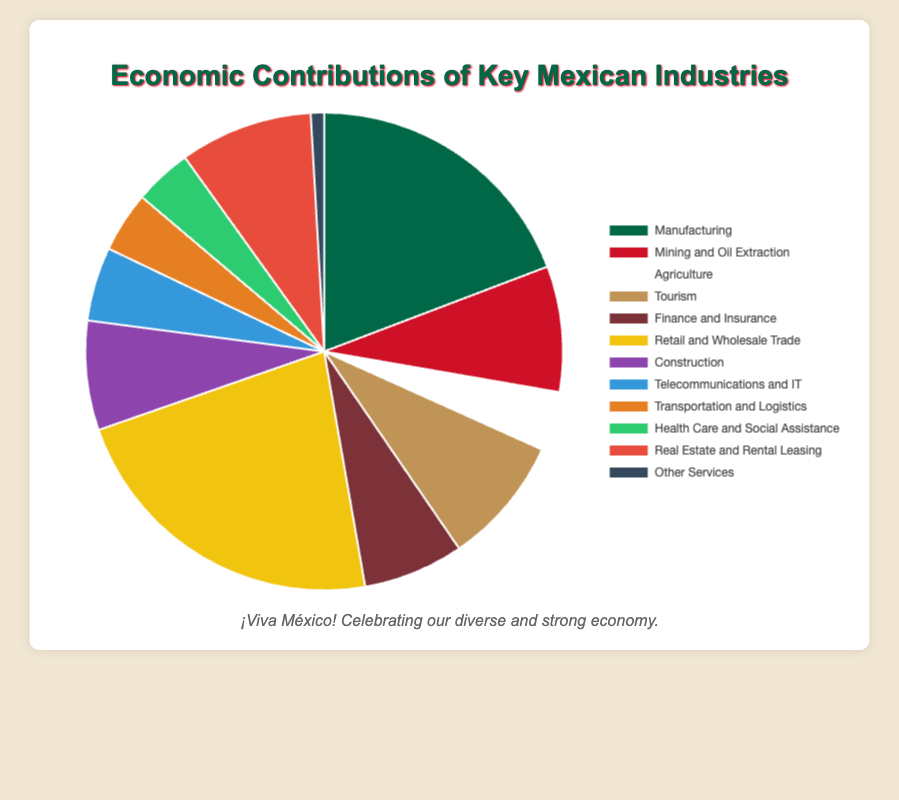What percentage of the economy does Manufacturing contribute? To determine the percentage, refer to the segment labeled "Manufacturing" in the pie chart.
Answer: 19.2% Which industry contributes more to the economy: Mining and Oil Extraction or Tourism? Compare the percentages: Mining and Oil Extraction contributes 8.5% while Tourism contributes 8.7%.
Answer: Tourism What is the total combined percentage of Agriculture, Construction, and Health Care and Social Assistance? Add the percentages of the three industries: Agriculture (4.0%) + Construction (7.4%) + Health Care and Social Assistance (3.9%) = 15.3%
Answer: 15.3% Which industry is depicted in blue and what percentage does it contribute? Identify the blue segment in the pie chart and check the corresponding label.
Answer: Telecommunications and IT, 5% By how much does Real Estate and Rental Leasing exceed Agriculture in their economic contributions? Subtract the percentage of Agriculture from that of Real Estate and Rental Leasing: 9.0% - 4.0% = 5.0%
Answer: 5.0% What percentage does the Retail and Wholesale Trade industry contribute to the economy? Look at the segment labeled "Retail and Wholesale Trade" in the pie chart.
Answer: 22.4% Arrange the following industries in ascending order of their economic contributions: Finance and Insurance, Transportation and Logistics, Real Estate and Rental Leasing. Compare the percentages of each industry: Transportation and Logistics (4.1%), Finance and Insurance (6.8%), Real Estate and Rental Leasing (9.0%).
Answer: Transportation and Logistics, Finance and Insurance, Real Estate and Rental Leasing Does Mining and Oil Extraction contribute more than Finance and Insurance to the economy? Compare the percentages of both industries: Mining and Oil Extraction (8.5%) and Finance and Insurance (6.8%).
Answer: Yes What is the visual representation color for the Banking subindustry? Since the chart only shows top-level industries visually and Banking is a subindustry, such details are not available in the pie chart.
Answer: Not shown in the pie chart Calculate the difference in economic contribution between Telecommunications and IT, and Health Care and Social Assistance. Subtract the percentage of Health Care and Social Assistance from that of Telecommunications and IT: 5.0% - 3.9% = 1.1%
Answer: 1.1% 